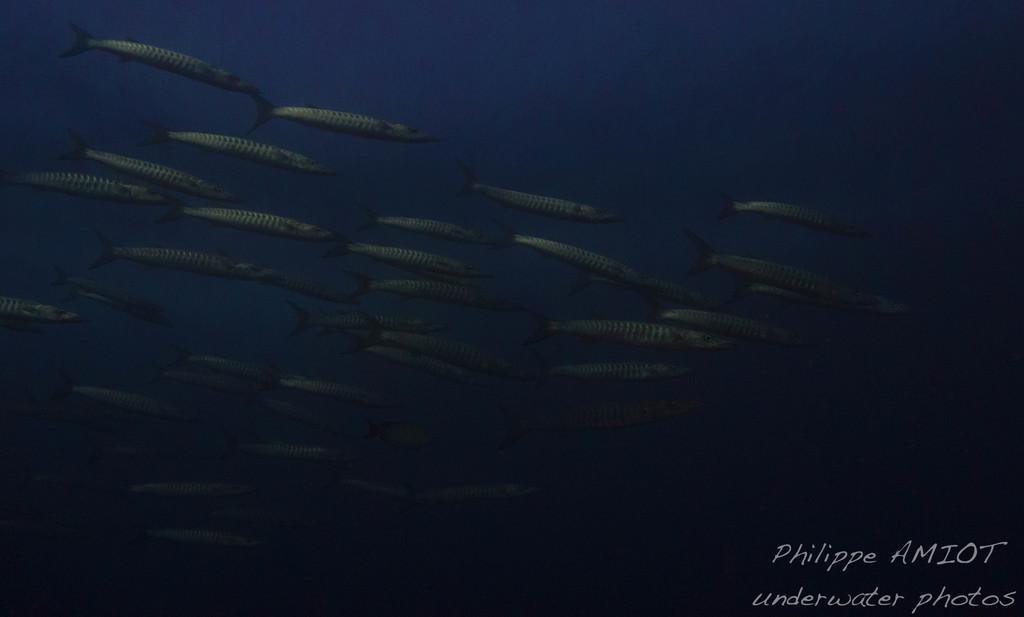Can you describe this image briefly? In this image I can see few fishes in blue color water. I can see a watermark at the bottom. 